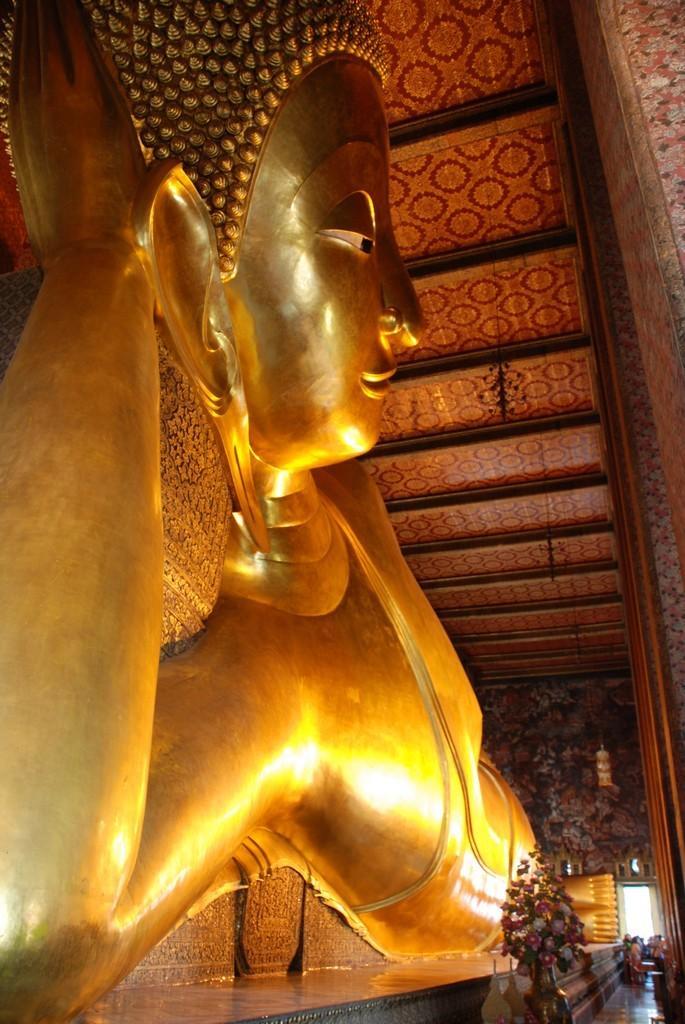Could you give a brief overview of what you see in this image? This is the picture of a room. On the left side of the image there is a sculpture on the wall. On the right side of the image there is a flower vase. At the back there are group of people standing at the door. At the top there is a floral painting on the roof. 